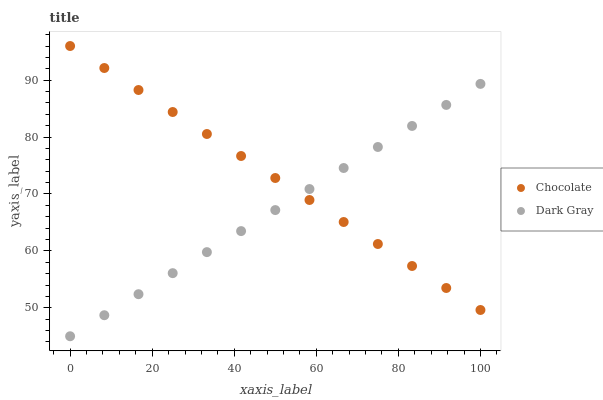Does Dark Gray have the minimum area under the curve?
Answer yes or no. Yes. Does Chocolate have the maximum area under the curve?
Answer yes or no. Yes. Does Chocolate have the minimum area under the curve?
Answer yes or no. No. Is Chocolate the smoothest?
Answer yes or no. Yes. Is Dark Gray the roughest?
Answer yes or no. Yes. Is Chocolate the roughest?
Answer yes or no. No. Does Dark Gray have the lowest value?
Answer yes or no. Yes. Does Chocolate have the lowest value?
Answer yes or no. No. Does Chocolate have the highest value?
Answer yes or no. Yes. Does Chocolate intersect Dark Gray?
Answer yes or no. Yes. Is Chocolate less than Dark Gray?
Answer yes or no. No. Is Chocolate greater than Dark Gray?
Answer yes or no. No. 